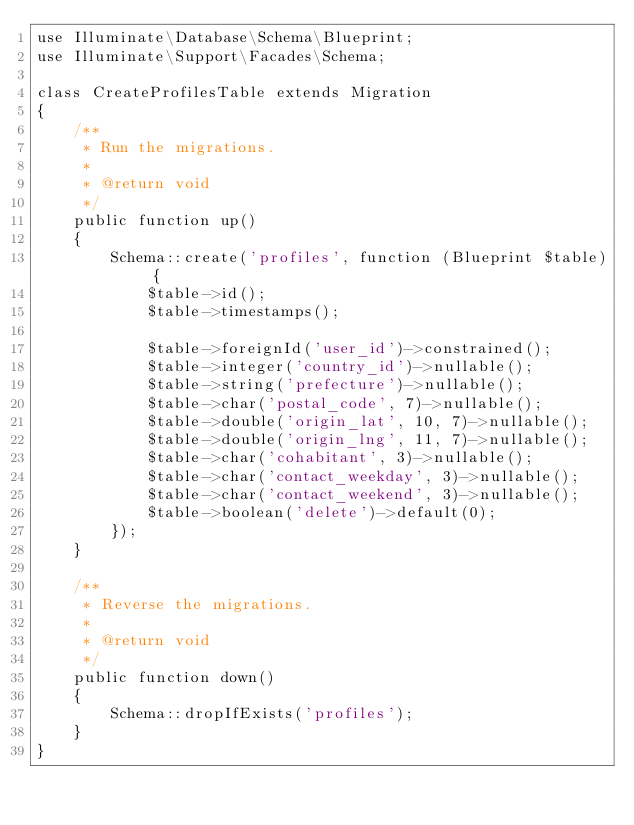<code> <loc_0><loc_0><loc_500><loc_500><_PHP_>use Illuminate\Database\Schema\Blueprint;
use Illuminate\Support\Facades\Schema;

class CreateProfilesTable extends Migration
{
    /**
     * Run the migrations.
     *
     * @return void
     */
    public function up()
    {
        Schema::create('profiles', function (Blueprint $table) {
            $table->id();
            $table->timestamps();

            $table->foreignId('user_id')->constrained();
            $table->integer('country_id')->nullable();
            $table->string('prefecture')->nullable();
            $table->char('postal_code', 7)->nullable();
            $table->double('origin_lat', 10, 7)->nullable();
            $table->double('origin_lng', 11, 7)->nullable();
            $table->char('cohabitant', 3)->nullable();
            $table->char('contact_weekday', 3)->nullable();
            $table->char('contact_weekend', 3)->nullable();
            $table->boolean('delete')->default(0);
        });
    }

    /**
     * Reverse the migrations.
     *
     * @return void
     */
    public function down()
    {
        Schema::dropIfExists('profiles');
    }
}
</code> 